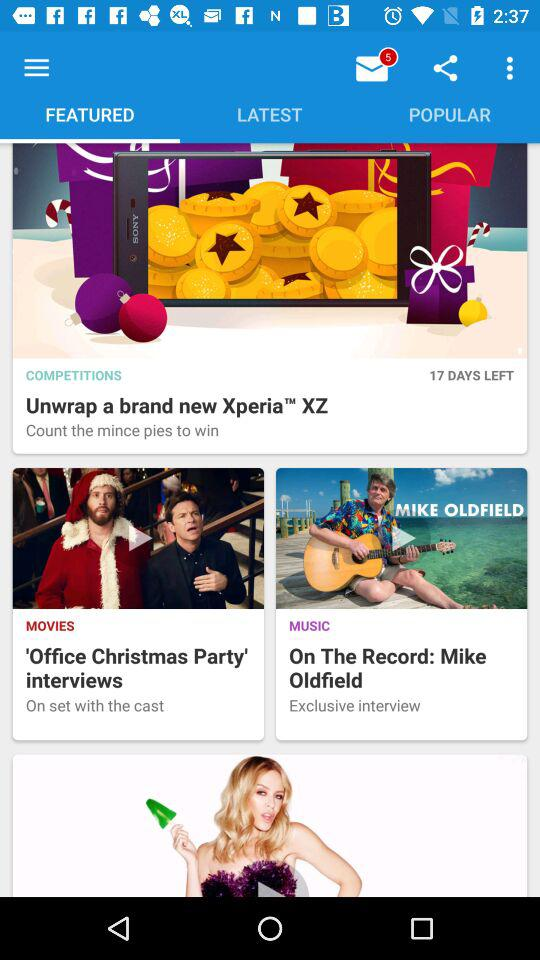How many different types of media are featured on this page?
Answer the question using a single word or phrase. 3 